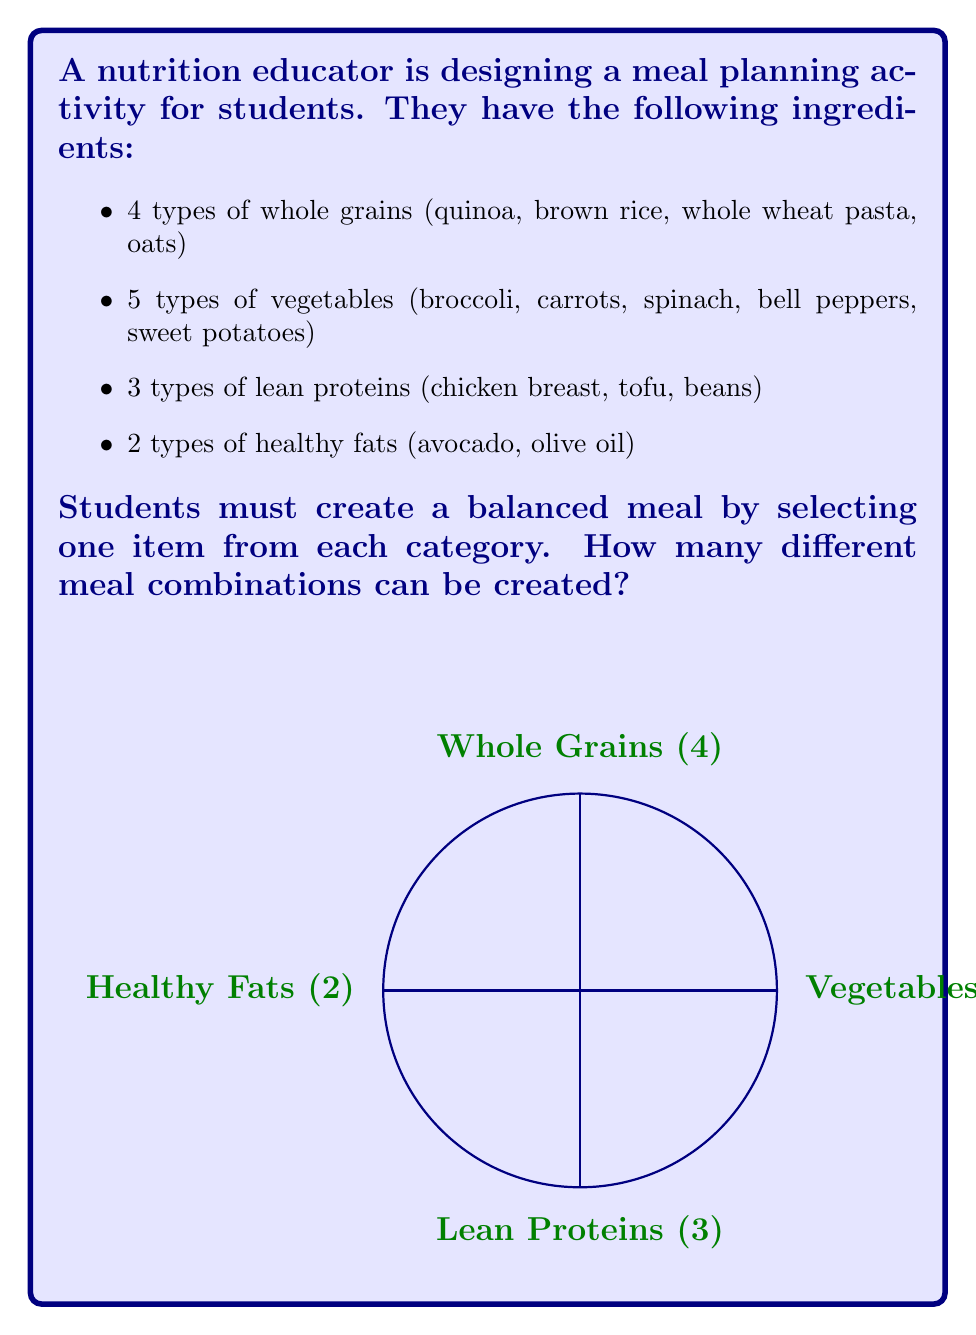Show me your answer to this math problem. To solve this problem, we'll use the multiplication principle of counting. This principle states that if we have a sequence of choices, and the number of options for each choice is independent of the other choices, then the total number of possible outcomes is the product of the number of options for each choice.

Let's break it down step-by-step:

1) For whole grains, there are 4 choices.
2) For vegetables, there are 5 choices.
3) For lean proteins, there are 3 choices.
4) For healthy fats, there are 2 choices.

Since we must choose one from each category, and the choice in one category doesn't affect the choices available in other categories, we multiply these numbers:

$$\text{Total combinations} = 4 \times 5 \times 3 \times 2$$

Calculating this:

$$\text{Total combinations} = 120$$

This means that students can create 120 different meal combinations using the given ingredients.

This problem demonstrates how combinatorics can be applied to nutrition education, helping students understand the variety of healthy meal options available from a limited set of ingredients.
Answer: 120 